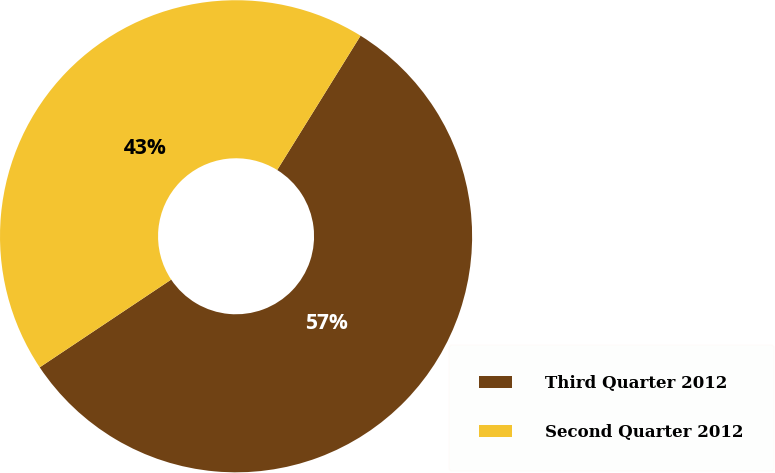Convert chart. <chart><loc_0><loc_0><loc_500><loc_500><pie_chart><fcel>Third Quarter 2012<fcel>Second Quarter 2012<nl><fcel>56.79%<fcel>43.21%<nl></chart> 